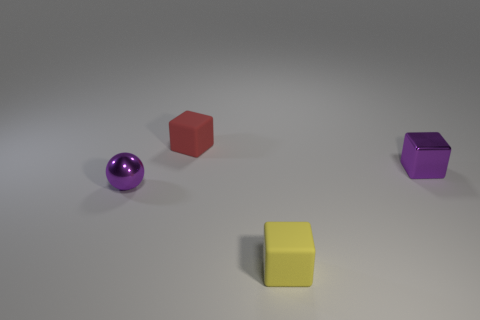What material is the object that is both to the right of the small red rubber object and in front of the small purple metal cube?
Your answer should be very brief. Rubber. The small block that is both to the right of the small red matte block and behind the ball is what color?
Provide a short and direct response. Purple. The small purple object that is right of the matte object behind the purple metallic object that is in front of the metal block is what shape?
Make the answer very short. Cube. The other tiny matte thing that is the same shape as the yellow thing is what color?
Your answer should be compact. Red. There is a small rubber cube that is behind the small yellow block that is left of the tiny purple cube; what is its color?
Provide a short and direct response. Red. What number of things have the same material as the purple ball?
Make the answer very short. 1. There is a small shiny thing on the right side of the yellow matte object; how many yellow matte blocks are behind it?
Give a very brief answer. 0. There is a tiny metallic ball; are there any small matte cubes in front of it?
Make the answer very short. Yes. Does the metallic thing on the right side of the red rubber cube have the same shape as the red matte thing?
Offer a terse response. Yes. What number of matte cubes are the same color as the ball?
Your answer should be compact. 0. 